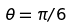Convert formula to latex. <formula><loc_0><loc_0><loc_500><loc_500>\theta = \pi / 6</formula> 